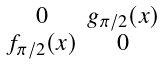<formula> <loc_0><loc_0><loc_500><loc_500>\begin{smallmatrix} 0 & g _ { \pi / 2 } ( x ) \\ f _ { \pi / 2 } ( x ) & 0 \end{smallmatrix}</formula> 